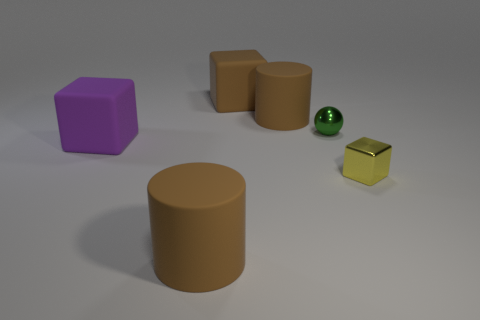Do the ball and the purple matte cube have the same size?
Offer a terse response. No. There is a large cylinder that is in front of the tiny yellow object; what is its material?
Your response must be concise. Rubber. How many other things are the same shape as the small yellow metal object?
Provide a succinct answer. 2. Is the shape of the tiny yellow thing the same as the green object?
Keep it short and to the point. No. There is a brown cube; are there any large matte cylinders right of it?
Your answer should be compact. Yes. How many objects are either big cyan objects or brown objects?
Your answer should be compact. 3. What number of other things are the same size as the yellow metallic thing?
Offer a terse response. 1. What number of things are right of the brown cube and behind the large purple rubber block?
Provide a succinct answer. 2. Does the matte cylinder that is in front of the tiny cube have the same size as the object that is right of the tiny shiny sphere?
Offer a very short reply. No. There is a matte cube that is left of the brown cube; what is its size?
Keep it short and to the point. Large. 